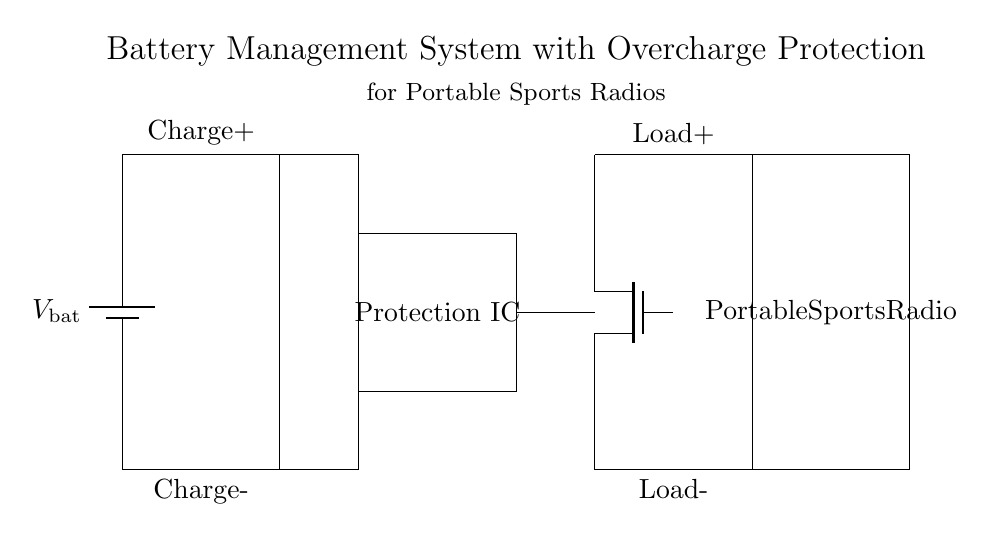What type of component is used for overcharge protection? The circuit includes a Protection IC, which is designed to monitor and prevent overcharging of the battery.
Answer: Protection IC What is the load connected to this battery management system? The load is labeled as a "Portable Sports Radio," indicating it is the device being powered by the battery.
Answer: Portable Sports Radio How many main components are in the circuit? By counting the main components (battery, charging circuit, protection IC, MOSFET, and load), there are five main components present in the circuit.
Answer: 5 What is the orientation of the battery symbol? The battery symbol is depicted vertically in the circuit diagram, typically representing a conventional view of a battery.
Answer: Vertical What role does the MOSFET play in this circuit? The MOSFET acts as a switch that is controlled by the Protection IC to regulate power delivery to the load, specifically helping with overcharge prevention.
Answer: Switch How is the charging circuit connected to the battery? The charging circuit connects directly to the positive and negative terminals of the battery at the top and bottom respectively, allowing current flow for charging.
Answer: Direct connection What is the purpose of the connection from the Protection IC to the MOSFET? This connection allows the Protection IC to control the MOSFET and effectively manage the power supplied to the load, preventing potential overcharging.
Answer: Control power management 